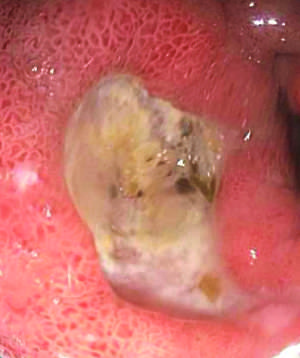how is endoscopic view of typical antral ulcer associated?
Answer the question using a single word or phrase. With nsaid use 